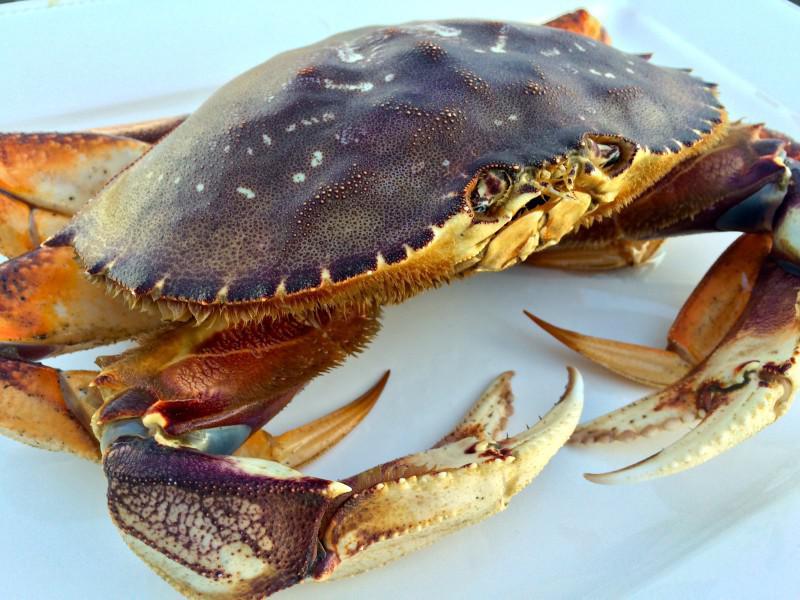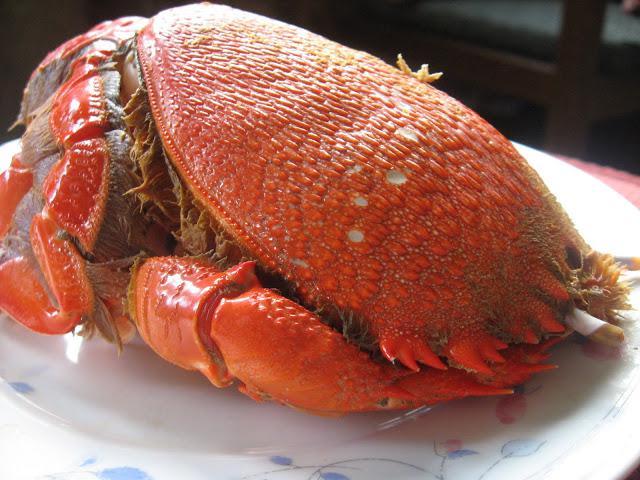The first image is the image on the left, the second image is the image on the right. For the images displayed, is the sentence "There are two crabs" factually correct? Answer yes or no. Yes. 